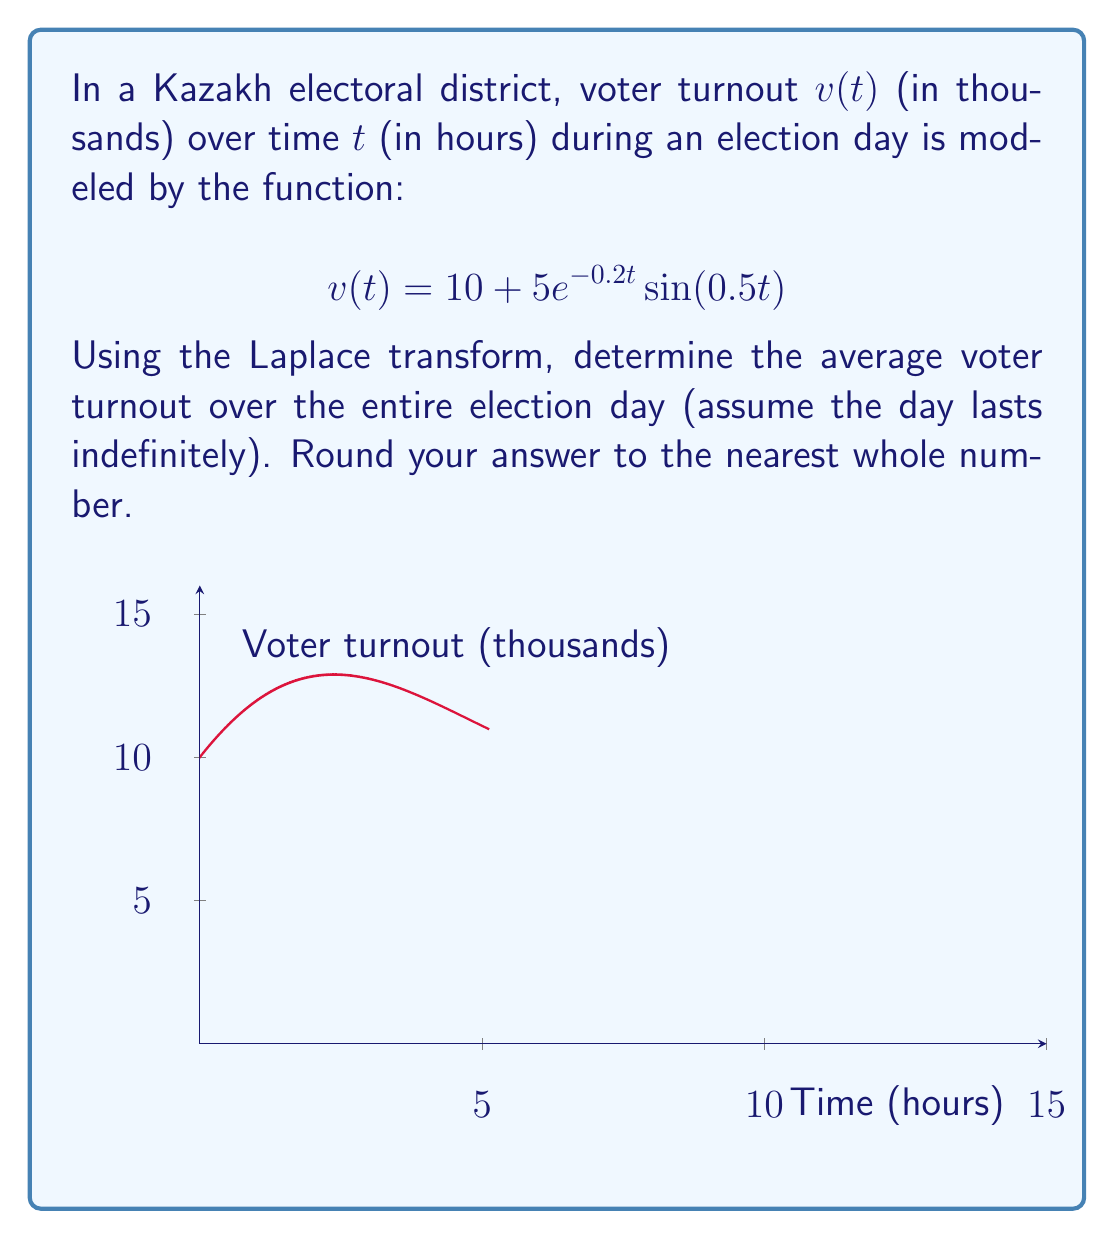Can you solve this math problem? To solve this problem using the Laplace transform, we'll follow these steps:

1) First, recall that the average value of a function over an infinite interval is given by the final value theorem:

   $$\lim_{t \to \infty} v(t) = \lim_{s \to 0} sV(s)$$

   where $V(s)$ is the Laplace transform of $v(t)$.

2) Let's find the Laplace transform of $v(t)$:

   $$\mathcal{L}\{v(t)\} = \mathcal{L}\{10\} + \mathcal{L}\{5e^{-0.2t}\sin(0.5t)\}$$

3) We know that:
   $$\mathcal{L}\{10\} = \frac{10}{s}$$
   $$\mathcal{L}\{e^{-at}\sin(bt)\} = \frac{b}{(s+a)^2 + b^2}$$

4) Applying these to our function:

   $$V(s) = \frac{10}{s} + 5\cdot\frac{0.5}{(s+0.2)^2 + 0.5^2}$$

5) Simplify:

   $$V(s) = \frac{10}{s} + \frac{2.5}{(s+0.2)^2 + 0.25}$$

6) Now, apply the final value theorem:

   $$\lim_{t \to \infty} v(t) = \lim_{s \to 0} s\left(\frac{10}{s} + \frac{2.5}{(s+0.2)^2 + 0.25}\right)$$

7) Evaluate the limit:

   $$\lim_{t \to \infty} v(t) = 10 + \lim_{s \to 0} \frac{2.5s}{(s+0.2)^2 + 0.25} = 10 + 0 = 10$$

8) Therefore, the average voter turnout over the entire election day is 10 thousand voters.
Answer: 10 thousand voters 